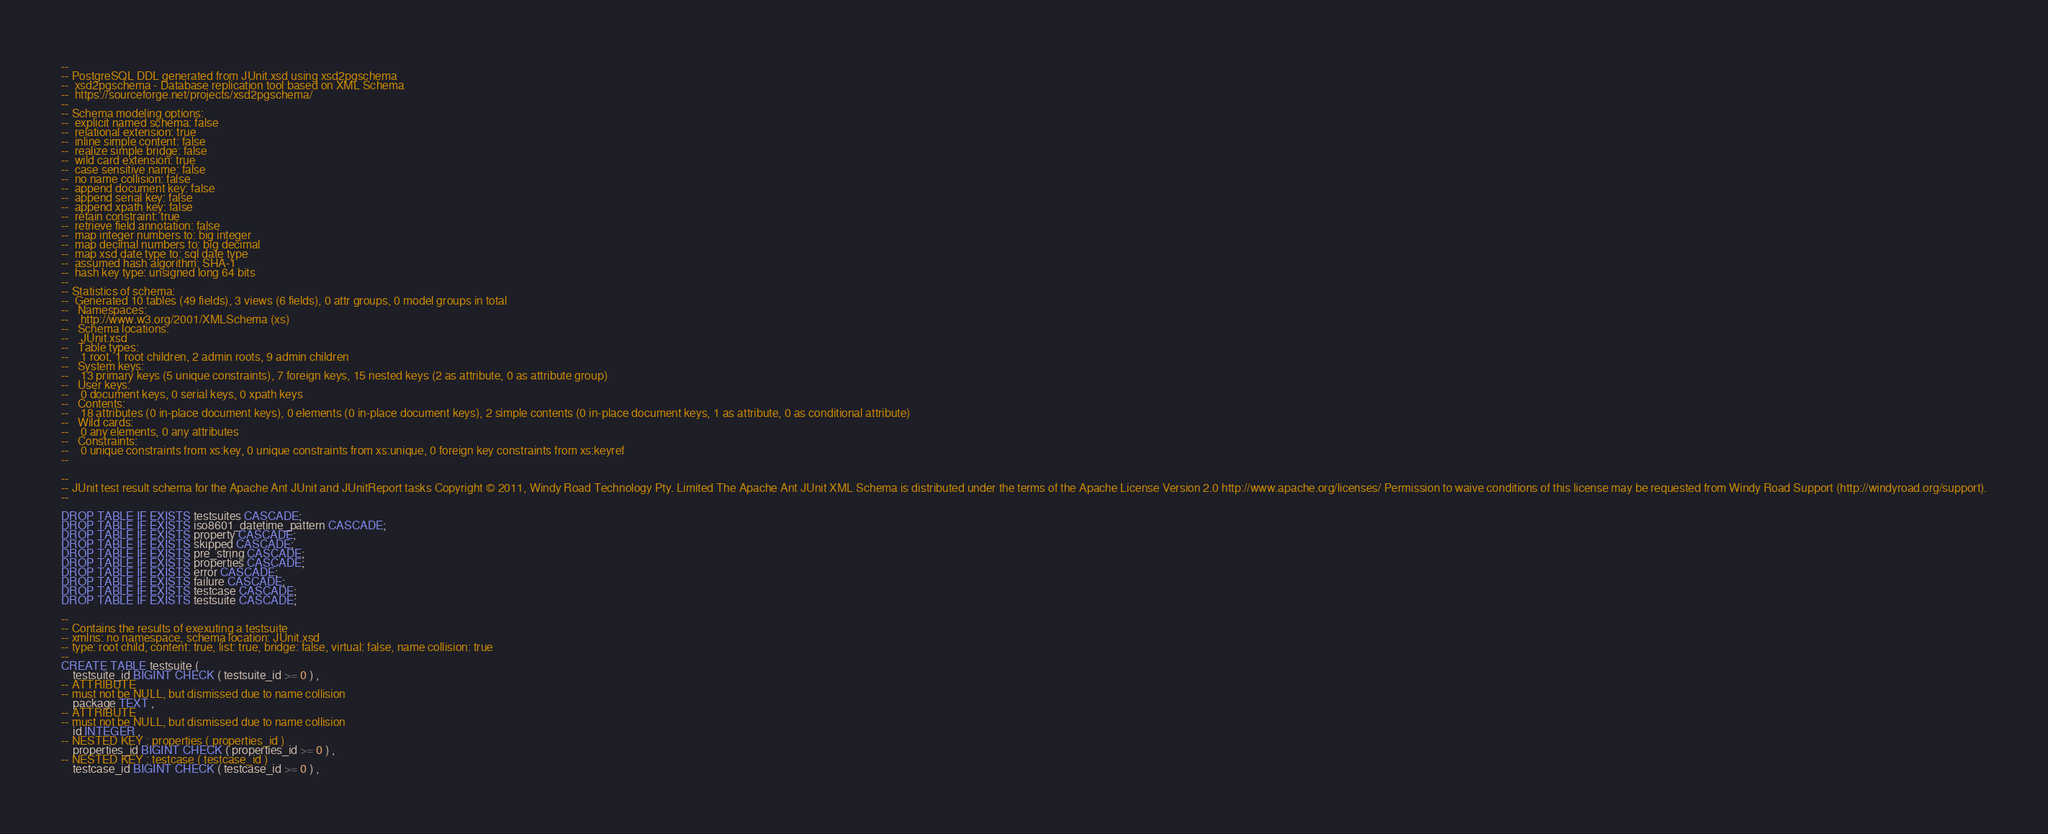<code> <loc_0><loc_0><loc_500><loc_500><_SQL_>--
-- PostgreSQL DDL generated from JUnit.xsd using xsd2pgschema
--  xsd2pgschema - Database replication tool based on XML Schema
--  https://sourceforge.net/projects/xsd2pgschema/
--
-- Schema modeling options:
--  explicit named schema: false
--  relational extension: true
--  inline simple content: false
--  realize simple bridge: false
--  wild card extension: true
--  case sensitive name: false
--  no name collision: false
--  append document key: false
--  append serial key: false
--  append xpath key: false
--  retain constraint: true
--  retrieve field annotation: false
--  map integer numbers to: big integer
--  map decimal numbers to: big decimal
--  map xsd date type to: sql date type
--  assumed hash algorithm: SHA-1
--  hash key type: unsigned long 64 bits
--
-- Statistics of schema:
--  Generated 10 tables (49 fields), 3 views (6 fields), 0 attr groups, 0 model groups in total
--   Namespaces:
--    http://www.w3.org/2001/XMLSchema (xs)
--   Schema locations:
--    JUnit.xsd
--   Table types:
--    1 root, 1 root children, 2 admin roots, 9 admin children
--   System keys:
--    13 primary keys (5 unique constraints), 7 foreign keys, 15 nested keys (2 as attribute, 0 as attribute group)
--   User keys:
--    0 document keys, 0 serial keys, 0 xpath keys
--   Contents:
--    18 attributes (0 in-place document keys), 0 elements (0 in-place document keys), 2 simple contents (0 in-place document keys, 1 as attribute, 0 as conditional attribute)
--   Wild cards:
--    0 any elements, 0 any attributes
--   Constraints:
--    0 unique constraints from xs:key, 0 unique constraints from xs:unique, 0 foreign key constraints from xs:keyref
--

--
-- JUnit test result schema for the Apache Ant JUnit and JUnitReport tasks Copyright © 2011, Windy Road Technology Pty. Limited The Apache Ant JUnit XML Schema is distributed under the terms of the Apache License Version 2.0 http://www.apache.org/licenses/ Permission to waive conditions of this license may be requested from Windy Road Support (http://windyroad.org/support).
--

DROP TABLE IF EXISTS testsuites CASCADE;
DROP TABLE IF EXISTS iso8601_datetime_pattern CASCADE;
DROP TABLE IF EXISTS property CASCADE;
DROP TABLE IF EXISTS skipped CASCADE;
DROP TABLE IF EXISTS pre_string CASCADE;
DROP TABLE IF EXISTS properties CASCADE;
DROP TABLE IF EXISTS error CASCADE;
DROP TABLE IF EXISTS failure CASCADE;
DROP TABLE IF EXISTS testcase CASCADE;
DROP TABLE IF EXISTS testsuite CASCADE;

--
-- Contains the results of exexuting a testsuite
-- xmlns: no namespace, schema location: JUnit.xsd
-- type: root child, content: true, list: true, bridge: false, virtual: false, name collision: true
--
CREATE TABLE testsuite (
	testsuite_id BIGINT CHECK ( testsuite_id >= 0 ) ,
-- ATTRIBUTE
-- must not be NULL, but dismissed due to name collision
	package TEXT ,
-- ATTRIBUTE
-- must not be NULL, but dismissed due to name collision
	id INTEGER ,
-- NESTED KEY : properties ( properties_id )
	properties_id BIGINT CHECK ( properties_id >= 0 ) ,
-- NESTED KEY : testcase ( testcase_id )
	testcase_id BIGINT CHECK ( testcase_id >= 0 ) ,</code> 